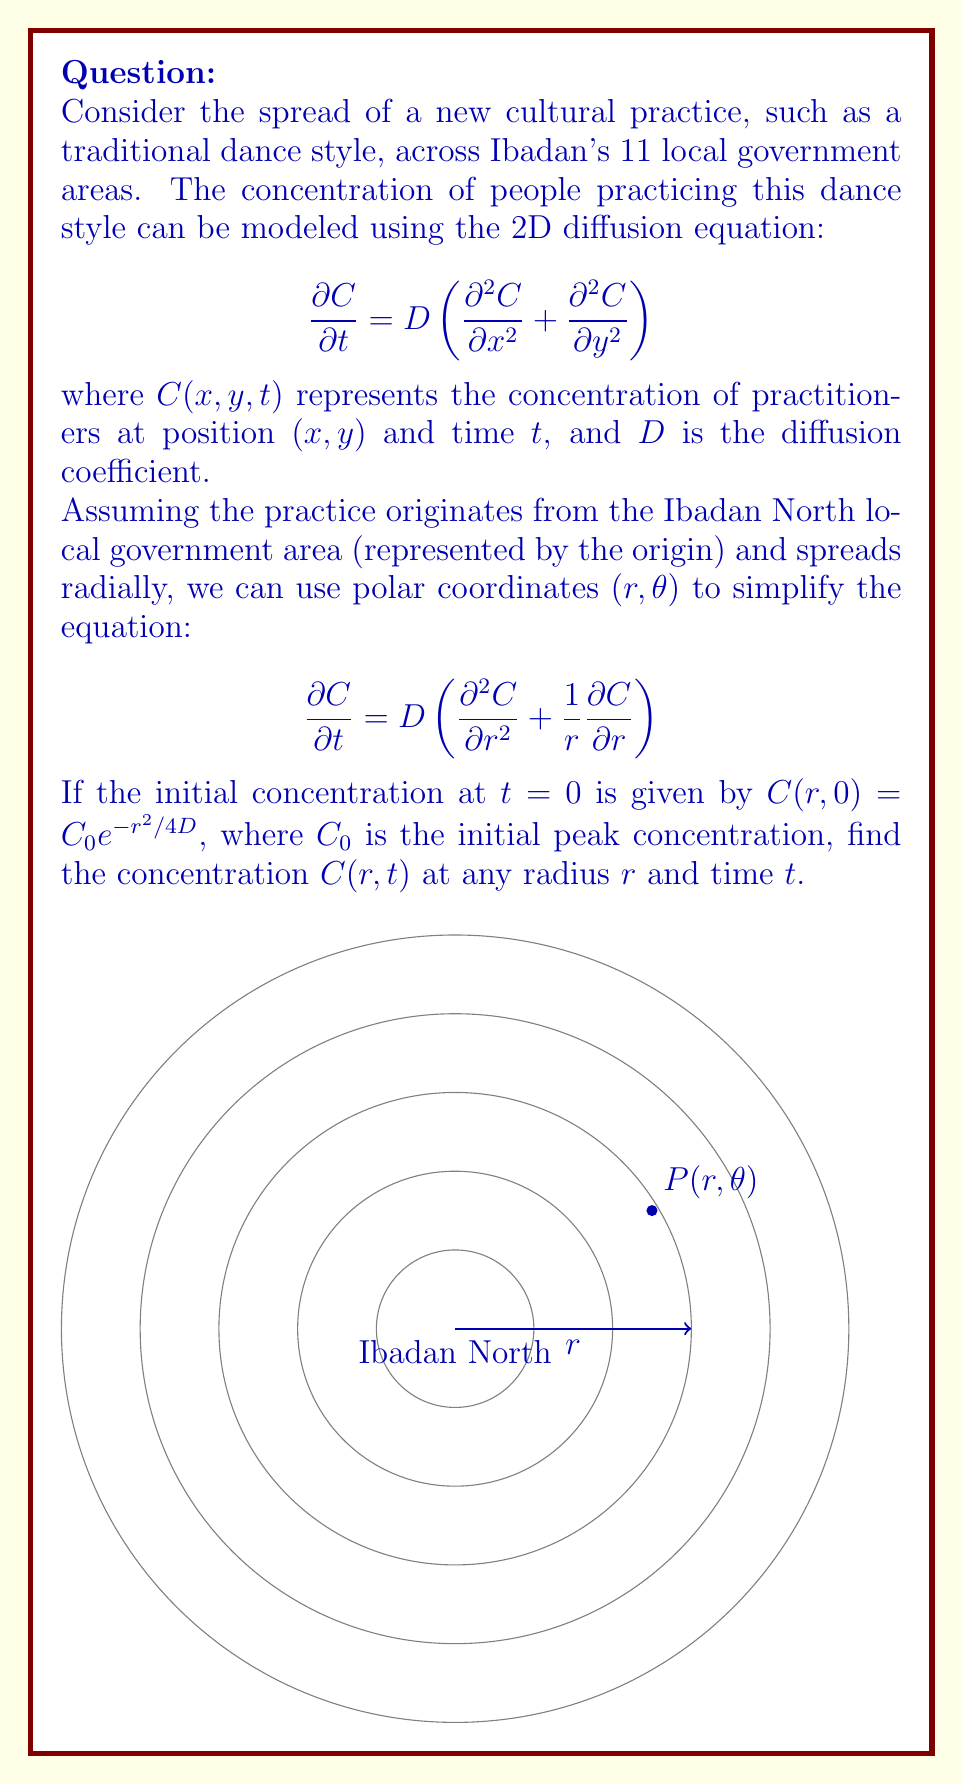Give your solution to this math problem. To solve this problem, we'll follow these steps:

1) The given equation is the radial form of the 2D diffusion equation. The general solution to this equation is:

   $$C(r,t) = \frac{A}{t+\tau}e^{-r^2/4D(t+\tau)}$$

   where $A$ and $\tau$ are constants to be determined from the initial conditions.

2) At $t=0$, we have:

   $$C(r,0) = \frac{A}{\tau}e^{-r^2/4D\tau} = C_0e^{-r^2/4D}$$

3) Comparing these expressions, we can deduce:

   $$\tau = 1$$
   $$A = C_0$$

4) Substituting these values back into the general solution:

   $$C(r,t) = \frac{C_0}{t+1}e^{-r^2/4D(t+1)}$$

5) This expression gives the concentration of practitioners at any radius $r$ and time $t$, starting from an initial Gaussian distribution centered at Ibadan North.

6) We can interpret this solution as follows:
   - The concentration decreases with time as $1/(t+1)$, reflecting the spread of the practice.
   - The exponential term shows how the practice spreads radially, with the width of the Gaussian increasing with time.
   - The diffusion coefficient $D$ determines how quickly the practice spreads; a larger $D$ means faster spread.
Answer: $C(r,t) = \frac{C_0}{t+1}e^{-r^2/4D(t+1)}$ 